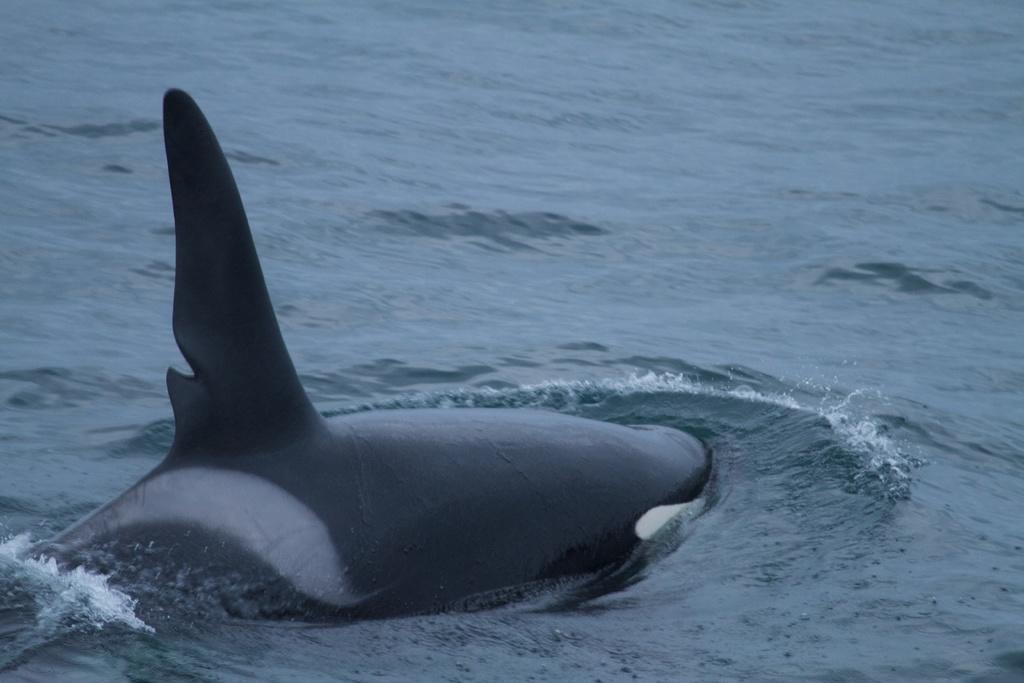What type of animal is in the image? There is a blue whale in the image. Where is the blue whale located? The blue whale is in the water. What type of hat is the blue whale wearing in the image? There is no hat present in the image; the blue whale is in the water. 